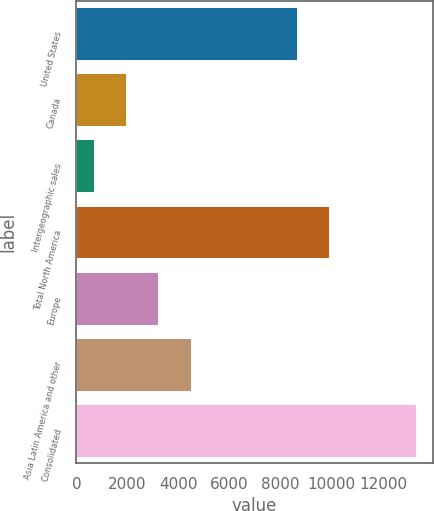Convert chart. <chart><loc_0><loc_0><loc_500><loc_500><bar_chart><fcel>United States<fcel>Canada<fcel>Intergeographic sales<fcel>Total North America<fcel>Europe<fcel>Asia Latin America and other<fcel>Consolidated<nl><fcel>8638.3<fcel>1953.99<fcel>694.7<fcel>9897.59<fcel>3213.28<fcel>4472.57<fcel>13287.6<nl></chart> 